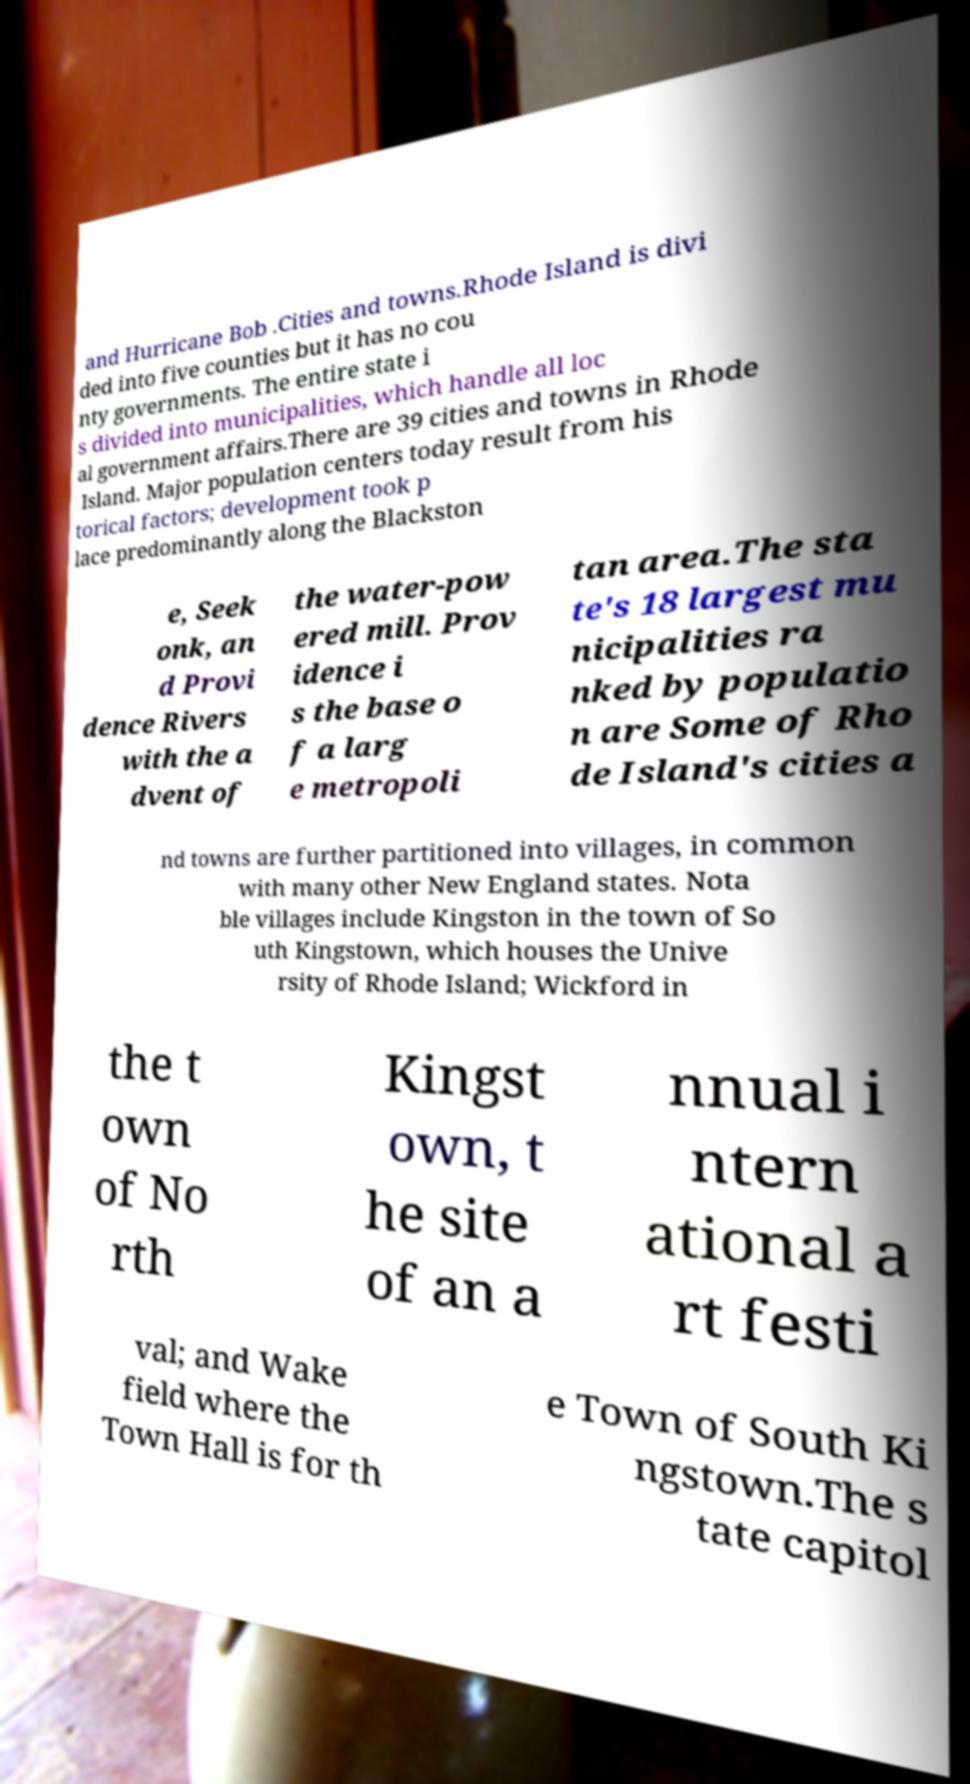Could you assist in decoding the text presented in this image and type it out clearly? and Hurricane Bob .Cities and towns.Rhode Island is divi ded into five counties but it has no cou nty governments. The entire state i s divided into municipalities, which handle all loc al government affairs.There are 39 cities and towns in Rhode Island. Major population centers today result from his torical factors; development took p lace predominantly along the Blackston e, Seek onk, an d Provi dence Rivers with the a dvent of the water-pow ered mill. Prov idence i s the base o f a larg e metropoli tan area.The sta te's 18 largest mu nicipalities ra nked by populatio n are Some of Rho de Island's cities a nd towns are further partitioned into villages, in common with many other New England states. Nota ble villages include Kingston in the town of So uth Kingstown, which houses the Unive rsity of Rhode Island; Wickford in the t own of No rth Kingst own, t he site of an a nnual i ntern ational a rt festi val; and Wake field where the Town Hall is for th e Town of South Ki ngstown.The s tate capitol 